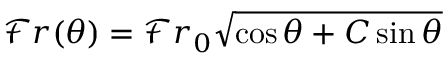<formula> <loc_0><loc_0><loc_500><loc_500>\mathcal { F } r ( \theta ) = \mathcal { F } r _ { 0 } \sqrt { \cos \theta + C \sin \theta }</formula> 